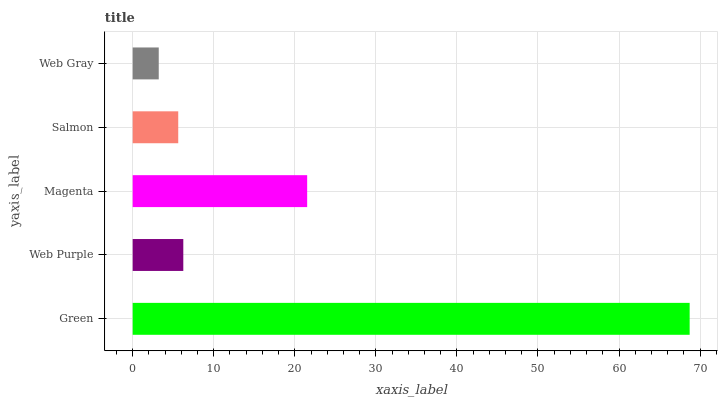Is Web Gray the minimum?
Answer yes or no. Yes. Is Green the maximum?
Answer yes or no. Yes. Is Web Purple the minimum?
Answer yes or no. No. Is Web Purple the maximum?
Answer yes or no. No. Is Green greater than Web Purple?
Answer yes or no. Yes. Is Web Purple less than Green?
Answer yes or no. Yes. Is Web Purple greater than Green?
Answer yes or no. No. Is Green less than Web Purple?
Answer yes or no. No. Is Web Purple the high median?
Answer yes or no. Yes. Is Web Purple the low median?
Answer yes or no. Yes. Is Web Gray the high median?
Answer yes or no. No. Is Magenta the low median?
Answer yes or no. No. 